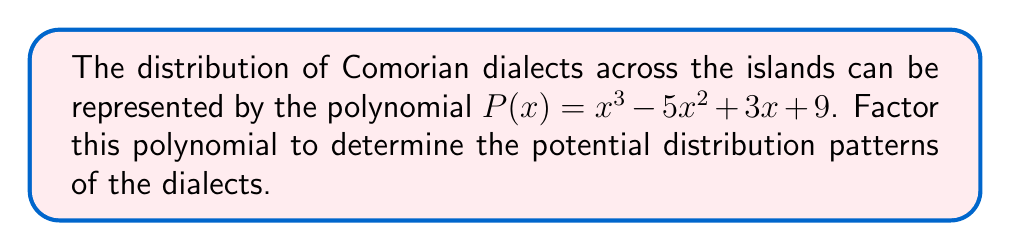Can you solve this math problem? Let's approach this step-by-step:

1) First, we need to check if there are any rational roots using the rational root theorem. The possible rational roots are the factors of the constant term: ±1, ±3, ±9.

2) Testing these values, we find that x = 3 is a root of the polynomial.

3) We can factor out (x - 3):
   $P(x) = (x - 3)(ax^2 + bx + c)$

4) Expanding this:
   $ax^3 + bx^2 + cx - 3ax^2 - 3bx - 3c = x^3 - 5x^2 + 3x + 9$

5) Comparing coefficients:
   $a = 1$
   $b - 3a = -5$, so $b = -2$
   $c - 3b = 3$, so $c = -3$

6) Therefore, 
   $P(x) = (x - 3)(x^2 - 2x - 3)$

7) The quadratic factor can be further factored:
   $x^2 - 2x - 3 = (x - 3)(x + 1)$

8) Thus, the final factorization is:
   $P(x) = (x - 3)(x - 3)(x + 1) = (x - 3)^2(x + 1)$

This factorization represents the distribution patterns of Comorian dialects across the islands.
Answer: $P(x) = (x - 3)^2(x + 1)$ 